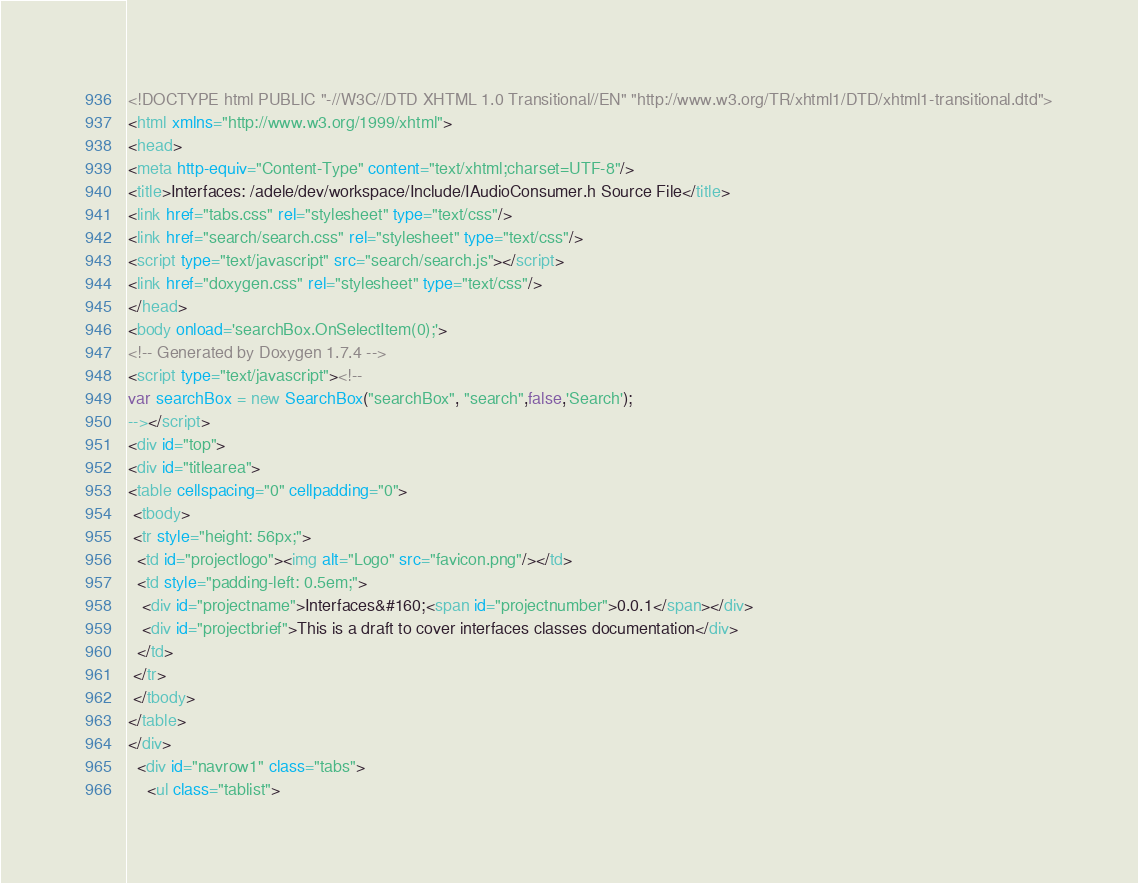Convert code to text. <code><loc_0><loc_0><loc_500><loc_500><_HTML_><!DOCTYPE html PUBLIC "-//W3C//DTD XHTML 1.0 Transitional//EN" "http://www.w3.org/TR/xhtml1/DTD/xhtml1-transitional.dtd">
<html xmlns="http://www.w3.org/1999/xhtml">
<head>
<meta http-equiv="Content-Type" content="text/xhtml;charset=UTF-8"/>
<title>Interfaces: /adele/dev/workspace/Include/IAudioConsumer.h Source File</title>
<link href="tabs.css" rel="stylesheet" type="text/css"/>
<link href="search/search.css" rel="stylesheet" type="text/css"/>
<script type="text/javascript" src="search/search.js"></script>
<link href="doxygen.css" rel="stylesheet" type="text/css"/>
</head>
<body onload='searchBox.OnSelectItem(0);'>
<!-- Generated by Doxygen 1.7.4 -->
<script type="text/javascript"><!--
var searchBox = new SearchBox("searchBox", "search",false,'Search');
--></script>
<div id="top">
<div id="titlearea">
<table cellspacing="0" cellpadding="0">
 <tbody>
 <tr style="height: 56px;">
  <td id="projectlogo"><img alt="Logo" src="favicon.png"/></td>
  <td style="padding-left: 0.5em;">
   <div id="projectname">Interfaces&#160;<span id="projectnumber">0.0.1</span></div>
   <div id="projectbrief">This is a draft to cover interfaces classes documentation</div>
  </td>
 </tr>
 </tbody>
</table>
</div>
  <div id="navrow1" class="tabs">
    <ul class="tablist"></code> 